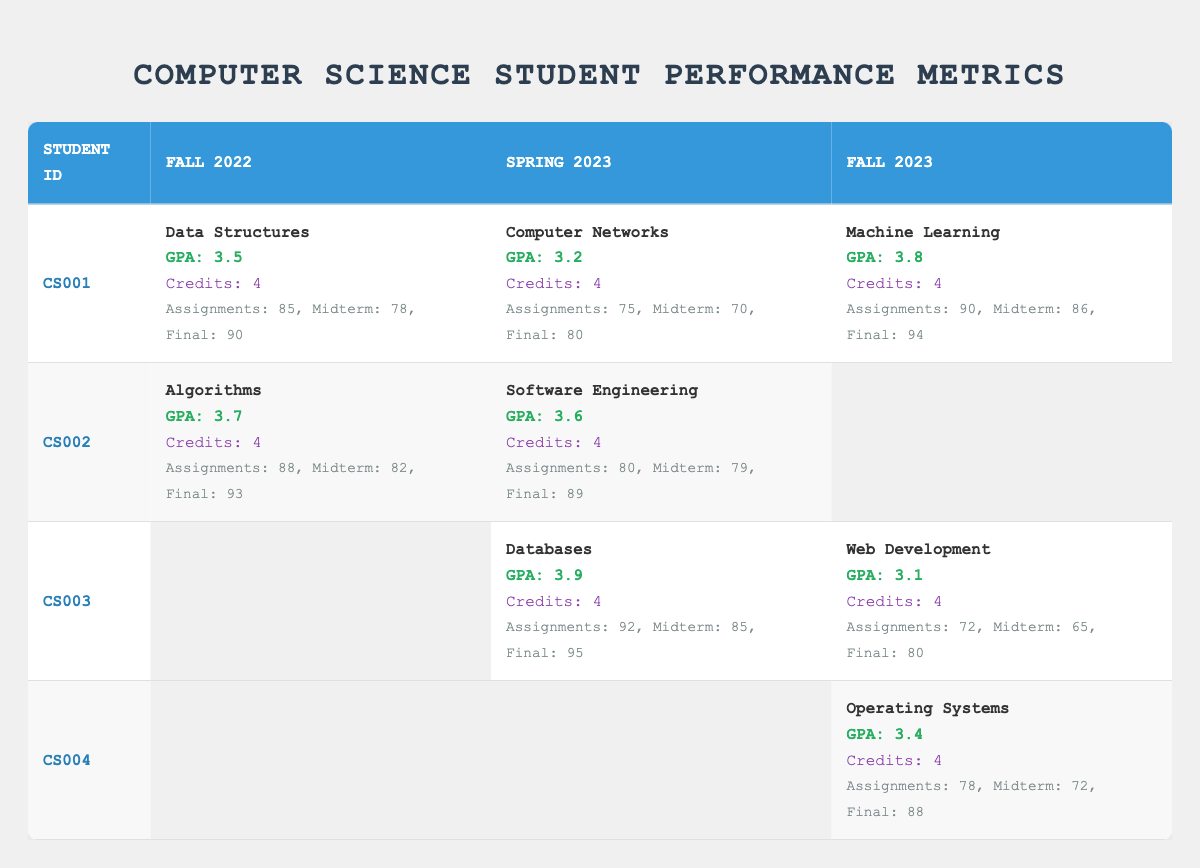What is the GPA of student CS002 in Fall 2022? In the table, locate student ID CS002 in the Fall 2022 column. The GPA listed there is 3.7.
Answer: 3.7 Which student received the highest GPA in Spring 2023? Look at the Spring 2023 GPAs of all students: CS001 has 3.2, CS002 has 3.6, and CS003 has 3.9. The highest GPA is 3.9 from CS003.
Answer: CS003 What course did student CS001 take in Fall 2023? Check the Fall 2023 column for student ID CS001. The course listed is Machine Learning.
Answer: Machine Learning Calculate the average GPA for student CS003 across all semesters. The GPAs for CS003 are not available for Fall 2022 (0 GPA considered), 3.9 for Spring 2023, and 3.1 for Fall 2023. Sum the GPAs: 0 + 3.9 + 3.1 = 7.0, and divide by 3 (number of semesters): 7.0 / 3 = 2.33.
Answer: 2.33 Did student CS004 take any courses in Spring 2023? Check the Spring 2023 column for student CS004. It shows empty, indicating CS004 did not take any course that semester.
Answer: No What is the difference between the highest and lowest GPA of student CS001 across all semesters? For CS001, the GPAs are 3.5 (Fall 2022), 3.2 (Spring 2023), and 3.8 (Fall 2023). The highest GPA is 3.8 and the lowest is 3.2. The difference is 3.8 - 3.2 = 0.6.
Answer: 0.6 Which student has the highest GPA in Fall 2023? Look at the Fall 2023 GPAs: CS001 has 3.8, CS003 has 3.1, and CS004 has 3.4. The highest is 3.8 from CS001.
Answer: CS001 If student CS002 improves their GPA by 0.2 in the next semester, what would it be? Current GPA for CS002 is 3.6 (Spring 2023). Adding 0.2 gives 3.6 + 0.2 = 3.8.
Answer: 3.8 What are the grades received by student CS003 in the Databases course? Referencing the Spring 2023 row for CS003, the grades listed are Assignments: 92, Midterm: 85, Final: 95.
Answer: Assignments: 92, Midterm: 85, Final: 95 Which course had the highest average assignment grade across all students who took it? Calculate average assignment grades for each course: Data Structures (85), Algorithms (88), Computer Networks (75), Databases (92), Software Engineering (80), Machine Learning (90), Web Development (72), Operating Systems (78). Average for Data Structures: 85; Algorithms: 88; Computer Networks: 75; Databases: 92; Software Engineering: 80; Machine Learning: 90; Web Development: 72; Operating Systems: 78. The highest is 92 for Databases.
Answer: Databases 